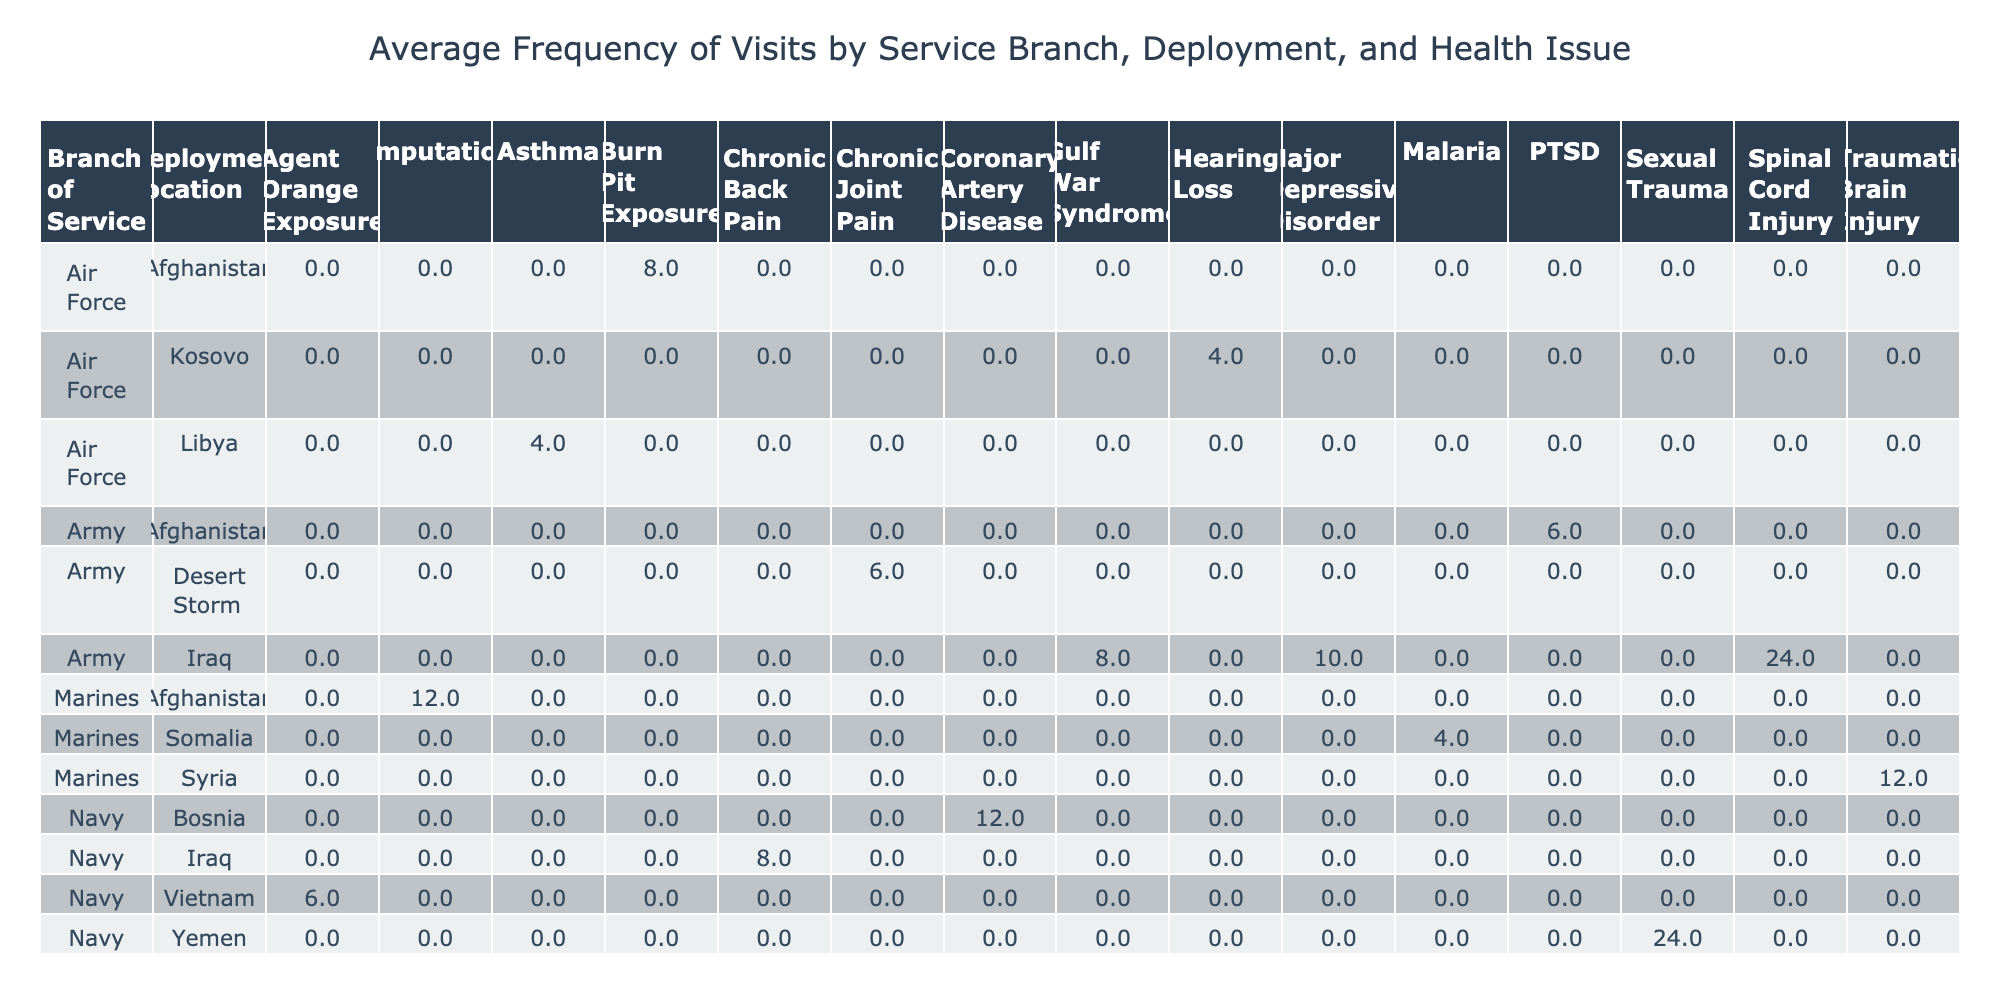What is the average frequency of visits for veterans who served in the Army at Iraq? Looking at the table, we see two entries under "Army" and "Iraq." One veteran has a frequency of visits of 6 per year, and the other has 24 per year. To find the average, we sum these values (6 + 24 = 30) and divide by the number of entries (2), resulting in an average of 15.
Answer: 15 Which branch of service has the highest recorded visits for veterans with PTSD? In the table, we identify veterans with PTSD. There are two such entries: one in the Army with 6 visits and one in the Navy with 12 visits. Comparing these, the Navy has the highest frequency of visits for veterans with PTSD, which is 12.
Answer: Navy Is there any veteran who was discharged in 2010 and has a secondary health issue of depression? In the table, under the row for the Navy with Iraq and the veteran discharged in 2010, we see that the primary health issue is chronic back pain and the secondary issue is depression. Hence, the answer to this specific inquiry is yes.
Answer: Yes What is the total frequency of visits for all veterans who served in the Marines? The table shows three veterans who served in the Marines with frequency of visits: one with 12, another with 4, and a third one with 12, making a total of visits 12 + 4 + 12 = 28 for all Marines veterans combined.
Answer: 28 What average frequency of visits is recorded for veterans with chronic back pain regardless of their branch? Looking at the table, only one veteran has chronic back pain (V002) with 8 visits per year. Since there is only one entry, the average is simply the frequency itself, which is 8.
Answer: 8 Are there any veterans who were discharged after 2015 with hearing loss? Scanning through the table, we note the discharge years and health issues. The only entry with hearing loss was discharged in 2005. Thus, the answer is no; no veterans with hearing loss were discharged after 2015.
Answer: No How many different primary health issues are represented for veterans deployed in Afghanistan? Reviewing the table, we see two veterans deployed in Afghanistan: one with PTSD and another with burn pit exposure. Thus, there are a total of two distinct primary health issues represented for veterans in this deployment location.
Answer: 2 What is the frequency of visits difference between veterans with major depressive disorder and chronic joint pain? From the table, one veteran has major depressive disorder with 10 visits, and another veteran has chronic joint pain with 6 visits. To find the difference, we subtract 6 from 10, resulting in a difference of 4.
Answer: 4 